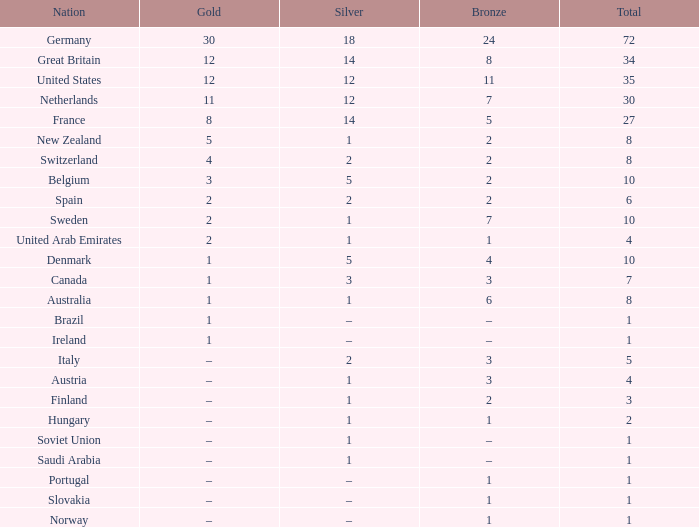What is Bronze, when Silver is 2, and when Nation is Italy? 3.0. 